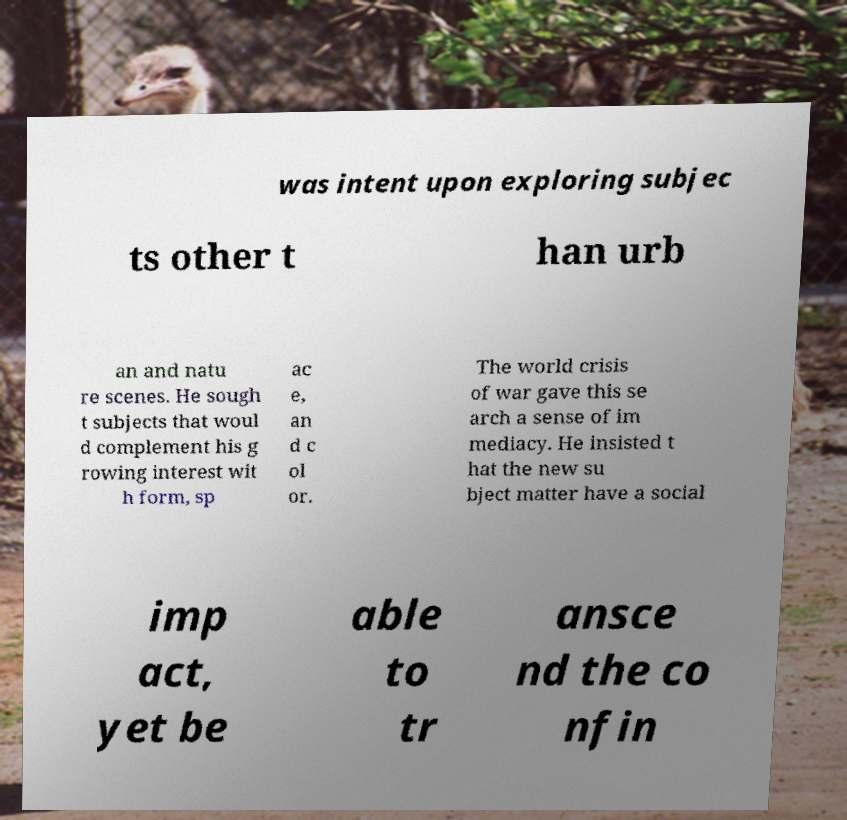There's text embedded in this image that I need extracted. Can you transcribe it verbatim? was intent upon exploring subjec ts other t han urb an and natu re scenes. He sough t subjects that woul d complement his g rowing interest wit h form, sp ac e, an d c ol or. The world crisis of war gave this se arch a sense of im mediacy. He insisted t hat the new su bject matter have a social imp act, yet be able to tr ansce nd the co nfin 